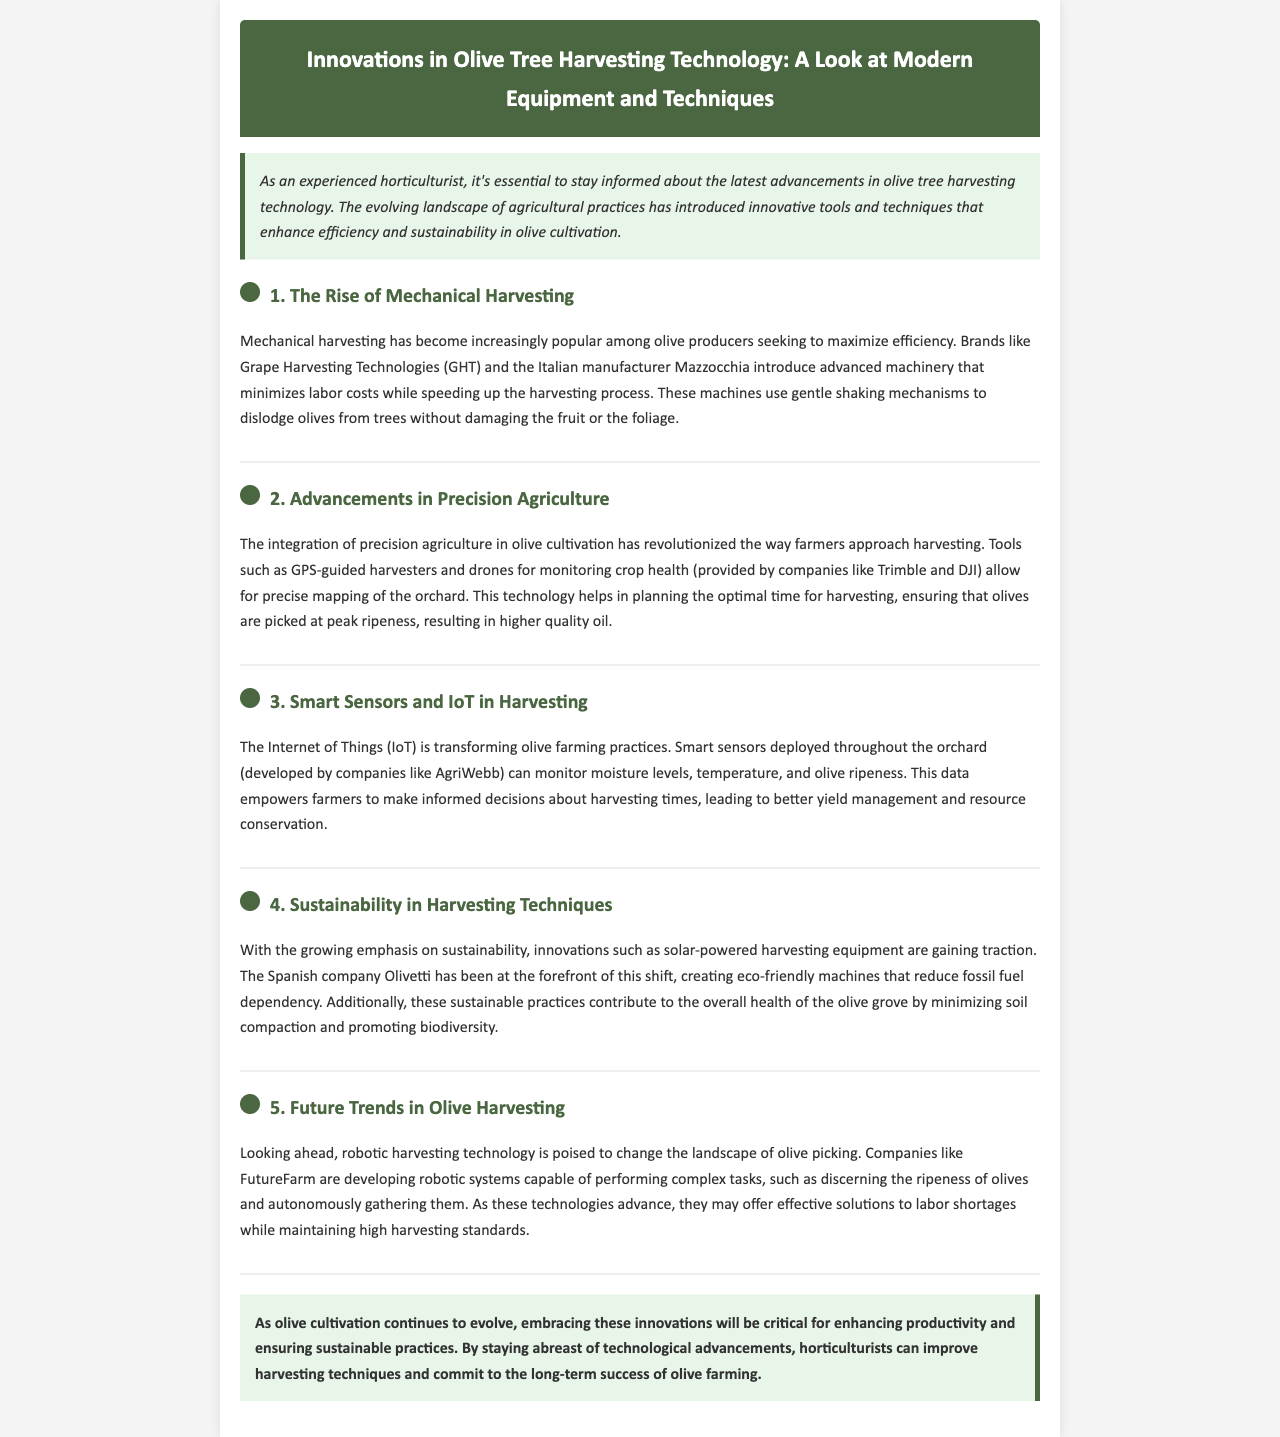What are the two brands mentioned that are pioneering mechanical harvesting? The document cites Grape Harvesting Technologies (GHT) and Mazzocchia as brands pioneering mechanical harvesting.
Answer: Grape Harvesting Technologies (GHT) and Mazzocchia What technology is used for monitoring crop health in olive orchards? The document mentions drones as a tool for monitoring crop health in olive orchards.
Answer: Drones Which company is associated with smart sensors for monitoring in the document? The document states that smart sensors are developed by AgriWebb for monitoring various conditions in the orchard.
Answer: AgriWebb What kind of harvesting equipment is gaining traction for its sustainability? The document highlights solar-powered harvesting equipment as an innovative sustainable practice.
Answer: Solar-powered harvesting equipment Which company is mentioned as focusing on robotic harvesting technology? FutureFarm is identified in the document as the company developing robotic systems for harvesting olives.
Answer: FutureFarm What is a benefit of using precision agriculture techniques in olive cultivation? The document notes that precision agriculture allows for precise mapping of the orchard and optimal harvesting timing.
Answer: Optimal harvesting timing What color is used for the header background in the newsletter? The background color of the header in the newsletter is specified as dark green (#4a6741).
Answer: Dark green How does mechanical harvesting impact labor costs? The document states that mechanical harvesting minimizes labor costs while speeding up the harvesting process.
Answer: Minimizes labor costs What is the overall theme of the newsletter? The document focuses on innovations in olive tree harvesting technology and modern equipment and techniques.
Answer: Innovations in olive tree harvesting technology 